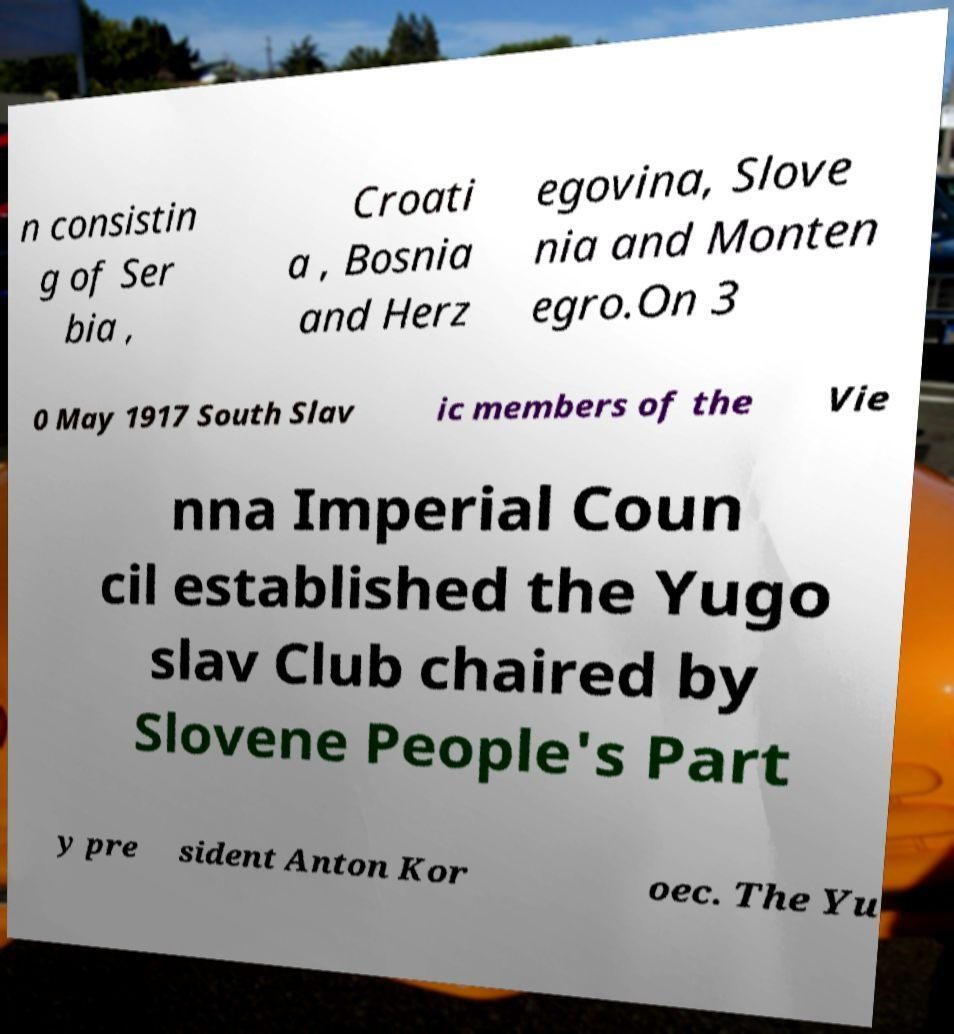For documentation purposes, I need the text within this image transcribed. Could you provide that? n consistin g of Ser bia , Croati a , Bosnia and Herz egovina, Slove nia and Monten egro.On 3 0 May 1917 South Slav ic members of the Vie nna Imperial Coun cil established the Yugo slav Club chaired by Slovene People's Part y pre sident Anton Kor oec. The Yu 